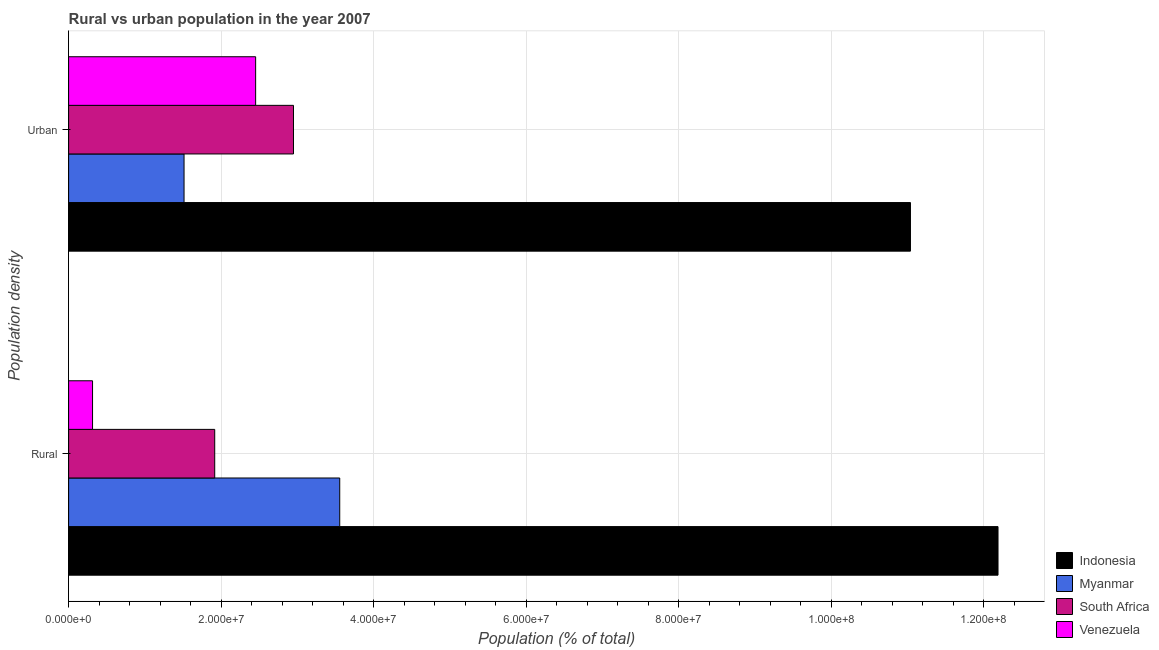How many different coloured bars are there?
Your response must be concise. 4. How many groups of bars are there?
Your answer should be very brief. 2. Are the number of bars per tick equal to the number of legend labels?
Your response must be concise. Yes. How many bars are there on the 2nd tick from the top?
Your answer should be compact. 4. How many bars are there on the 1st tick from the bottom?
Offer a very short reply. 4. What is the label of the 2nd group of bars from the top?
Offer a terse response. Rural. What is the rural population density in Indonesia?
Offer a very short reply. 1.22e+08. Across all countries, what is the maximum urban population density?
Make the answer very short. 1.10e+08. Across all countries, what is the minimum urban population density?
Your answer should be very brief. 1.51e+07. In which country was the urban population density maximum?
Provide a succinct answer. Indonesia. In which country was the urban population density minimum?
Make the answer very short. Myanmar. What is the total rural population density in the graph?
Offer a very short reply. 1.80e+08. What is the difference between the urban population density in Venezuela and that in Myanmar?
Give a very brief answer. 9.39e+06. What is the difference between the rural population density in Venezuela and the urban population density in Indonesia?
Offer a very short reply. -1.07e+08. What is the average rural population density per country?
Make the answer very short. 4.49e+07. What is the difference between the urban population density and rural population density in Myanmar?
Ensure brevity in your answer.  -2.04e+07. What is the ratio of the urban population density in Indonesia to that in Myanmar?
Give a very brief answer. 7.29. What does the 1st bar from the top in Rural represents?
Your answer should be compact. Venezuela. How many bars are there?
Provide a succinct answer. 8. Are all the bars in the graph horizontal?
Give a very brief answer. Yes. Are the values on the major ticks of X-axis written in scientific E-notation?
Give a very brief answer. Yes. Does the graph contain grids?
Provide a short and direct response. Yes. Where does the legend appear in the graph?
Keep it short and to the point. Bottom right. How are the legend labels stacked?
Make the answer very short. Vertical. What is the title of the graph?
Keep it short and to the point. Rural vs urban population in the year 2007. What is the label or title of the X-axis?
Provide a succinct answer. Population (% of total). What is the label or title of the Y-axis?
Provide a short and direct response. Population density. What is the Population (% of total) of Indonesia in Rural?
Your answer should be very brief. 1.22e+08. What is the Population (% of total) of Myanmar in Rural?
Make the answer very short. 3.56e+07. What is the Population (% of total) in South Africa in Rural?
Give a very brief answer. 1.92e+07. What is the Population (% of total) of Venezuela in Rural?
Offer a terse response. 3.14e+06. What is the Population (% of total) in Indonesia in Urban?
Your response must be concise. 1.10e+08. What is the Population (% of total) in Myanmar in Urban?
Your answer should be compact. 1.51e+07. What is the Population (% of total) of South Africa in Urban?
Make the answer very short. 2.95e+07. What is the Population (% of total) of Venezuela in Urban?
Keep it short and to the point. 2.45e+07. Across all Population density, what is the maximum Population (% of total) of Indonesia?
Offer a terse response. 1.22e+08. Across all Population density, what is the maximum Population (% of total) in Myanmar?
Your answer should be compact. 3.56e+07. Across all Population density, what is the maximum Population (% of total) in South Africa?
Ensure brevity in your answer.  2.95e+07. Across all Population density, what is the maximum Population (% of total) in Venezuela?
Ensure brevity in your answer.  2.45e+07. Across all Population density, what is the minimum Population (% of total) of Indonesia?
Your response must be concise. 1.10e+08. Across all Population density, what is the minimum Population (% of total) in Myanmar?
Provide a succinct answer. 1.51e+07. Across all Population density, what is the minimum Population (% of total) in South Africa?
Provide a succinct answer. 1.92e+07. Across all Population density, what is the minimum Population (% of total) of Venezuela?
Your answer should be compact. 3.14e+06. What is the total Population (% of total) of Indonesia in the graph?
Offer a very short reply. 2.32e+08. What is the total Population (% of total) of Myanmar in the graph?
Offer a very short reply. 5.07e+07. What is the total Population (% of total) of South Africa in the graph?
Your answer should be very brief. 4.87e+07. What is the total Population (% of total) of Venezuela in the graph?
Your answer should be very brief. 2.77e+07. What is the difference between the Population (% of total) in Indonesia in Rural and that in Urban?
Offer a terse response. 1.15e+07. What is the difference between the Population (% of total) in Myanmar in Rural and that in Urban?
Your response must be concise. 2.04e+07. What is the difference between the Population (% of total) in South Africa in Rural and that in Urban?
Keep it short and to the point. -1.03e+07. What is the difference between the Population (% of total) in Venezuela in Rural and that in Urban?
Offer a very short reply. -2.14e+07. What is the difference between the Population (% of total) of Indonesia in Rural and the Population (% of total) of Myanmar in Urban?
Provide a short and direct response. 1.07e+08. What is the difference between the Population (% of total) in Indonesia in Rural and the Population (% of total) in South Africa in Urban?
Your response must be concise. 9.24e+07. What is the difference between the Population (% of total) of Indonesia in Rural and the Population (% of total) of Venezuela in Urban?
Your answer should be compact. 9.74e+07. What is the difference between the Population (% of total) in Myanmar in Rural and the Population (% of total) in South Africa in Urban?
Offer a very short reply. 6.06e+06. What is the difference between the Population (% of total) of Myanmar in Rural and the Population (% of total) of Venezuela in Urban?
Ensure brevity in your answer.  1.10e+07. What is the difference between the Population (% of total) in South Africa in Rural and the Population (% of total) in Venezuela in Urban?
Provide a succinct answer. -5.37e+06. What is the average Population (% of total) of Indonesia per Population density?
Keep it short and to the point. 1.16e+08. What is the average Population (% of total) in Myanmar per Population density?
Keep it short and to the point. 2.53e+07. What is the average Population (% of total) in South Africa per Population density?
Provide a short and direct response. 2.43e+07. What is the average Population (% of total) in Venezuela per Population density?
Your answer should be very brief. 1.38e+07. What is the difference between the Population (% of total) of Indonesia and Population (% of total) of Myanmar in Rural?
Your answer should be compact. 8.63e+07. What is the difference between the Population (% of total) in Indonesia and Population (% of total) in South Africa in Rural?
Your answer should be compact. 1.03e+08. What is the difference between the Population (% of total) in Indonesia and Population (% of total) in Venezuela in Rural?
Provide a succinct answer. 1.19e+08. What is the difference between the Population (% of total) of Myanmar and Population (% of total) of South Africa in Rural?
Offer a terse response. 1.64e+07. What is the difference between the Population (% of total) in Myanmar and Population (% of total) in Venezuela in Rural?
Make the answer very short. 3.24e+07. What is the difference between the Population (% of total) in South Africa and Population (% of total) in Venezuela in Rural?
Give a very brief answer. 1.60e+07. What is the difference between the Population (% of total) in Indonesia and Population (% of total) in Myanmar in Urban?
Ensure brevity in your answer.  9.53e+07. What is the difference between the Population (% of total) in Indonesia and Population (% of total) in South Africa in Urban?
Provide a short and direct response. 8.09e+07. What is the difference between the Population (% of total) of Indonesia and Population (% of total) of Venezuela in Urban?
Provide a short and direct response. 8.59e+07. What is the difference between the Population (% of total) of Myanmar and Population (% of total) of South Africa in Urban?
Make the answer very short. -1.44e+07. What is the difference between the Population (% of total) in Myanmar and Population (% of total) in Venezuela in Urban?
Provide a succinct answer. -9.39e+06. What is the difference between the Population (% of total) in South Africa and Population (% of total) in Venezuela in Urban?
Your answer should be compact. 4.96e+06. What is the ratio of the Population (% of total) of Indonesia in Rural to that in Urban?
Provide a short and direct response. 1.1. What is the ratio of the Population (% of total) of Myanmar in Rural to that in Urban?
Provide a short and direct response. 2.35. What is the ratio of the Population (% of total) of South Africa in Rural to that in Urban?
Make the answer very short. 0.65. What is the ratio of the Population (% of total) in Venezuela in Rural to that in Urban?
Provide a succinct answer. 0.13. What is the difference between the highest and the second highest Population (% of total) in Indonesia?
Provide a succinct answer. 1.15e+07. What is the difference between the highest and the second highest Population (% of total) of Myanmar?
Your response must be concise. 2.04e+07. What is the difference between the highest and the second highest Population (% of total) of South Africa?
Provide a succinct answer. 1.03e+07. What is the difference between the highest and the second highest Population (% of total) in Venezuela?
Your answer should be very brief. 2.14e+07. What is the difference between the highest and the lowest Population (% of total) of Indonesia?
Make the answer very short. 1.15e+07. What is the difference between the highest and the lowest Population (% of total) in Myanmar?
Provide a succinct answer. 2.04e+07. What is the difference between the highest and the lowest Population (% of total) in South Africa?
Offer a very short reply. 1.03e+07. What is the difference between the highest and the lowest Population (% of total) of Venezuela?
Your response must be concise. 2.14e+07. 